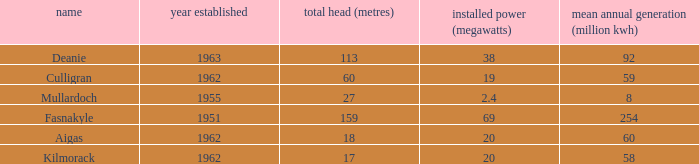What is the Year commissioned of the power station with a Gross head of 60 metres and Average annual output of less than 59 million KWh? None. Parse the table in full. {'header': ['name', 'year established', 'total head (metres)', 'installed power (megawatts)', 'mean annual generation (million kwh)'], 'rows': [['Deanie', '1963', '113', '38', '92'], ['Culligran', '1962', '60', '19', '59'], ['Mullardoch', '1955', '27', '2.4', '8'], ['Fasnakyle', '1951', '159', '69', '254'], ['Aigas', '1962', '18', '20', '60'], ['Kilmorack', '1962', '17', '20', '58']]} 